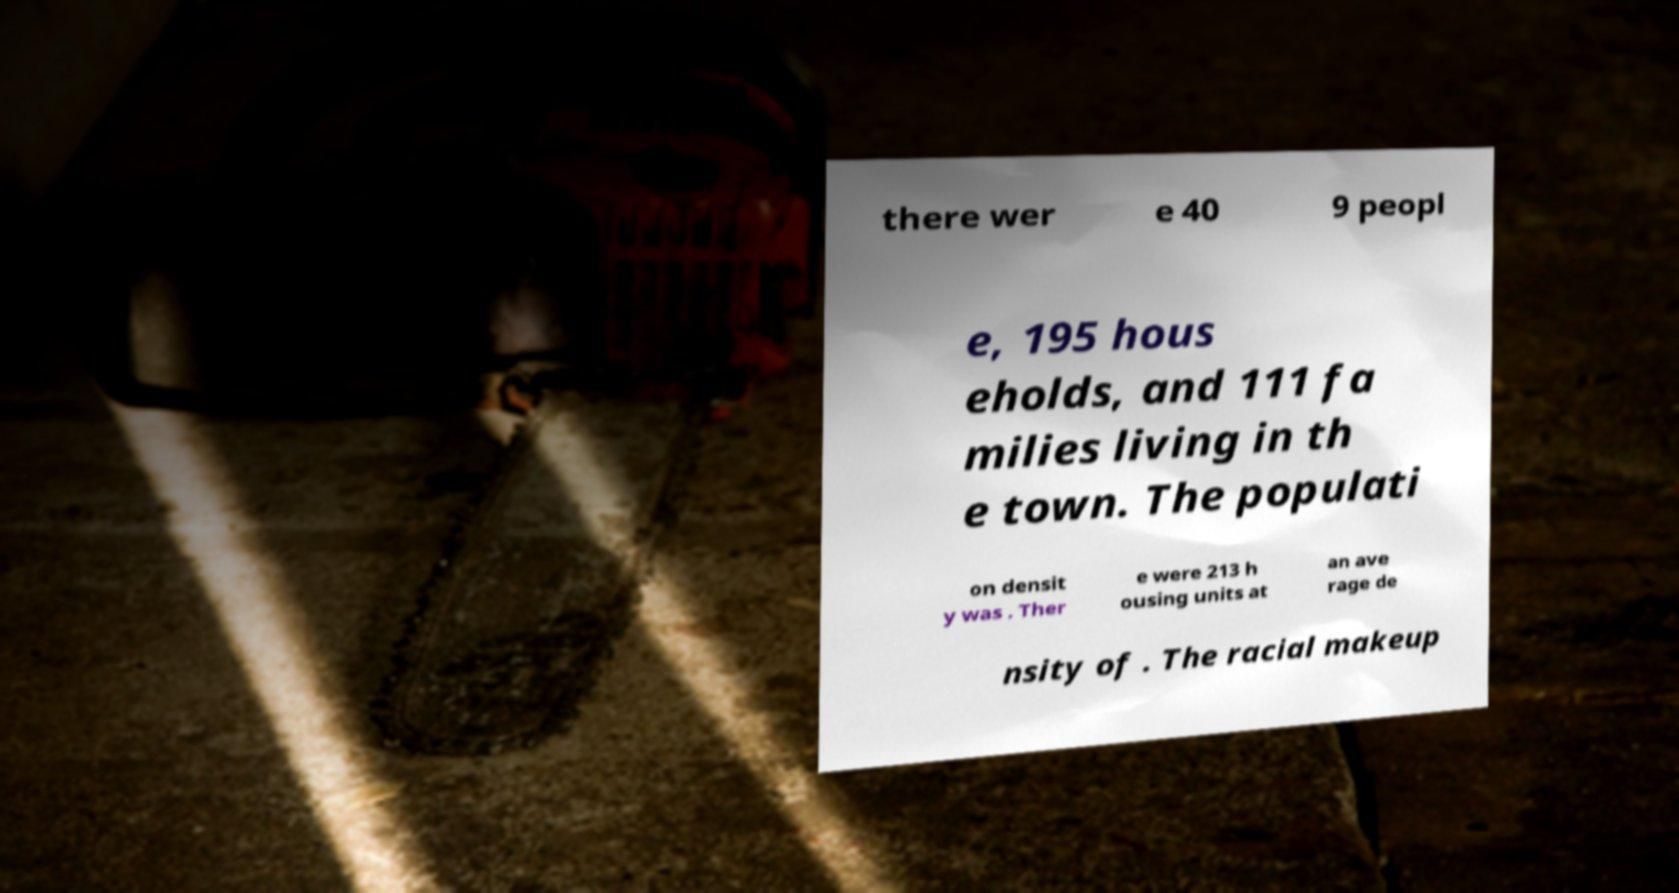I need the written content from this picture converted into text. Can you do that? there wer e 40 9 peopl e, 195 hous eholds, and 111 fa milies living in th e town. The populati on densit y was . Ther e were 213 h ousing units at an ave rage de nsity of . The racial makeup 